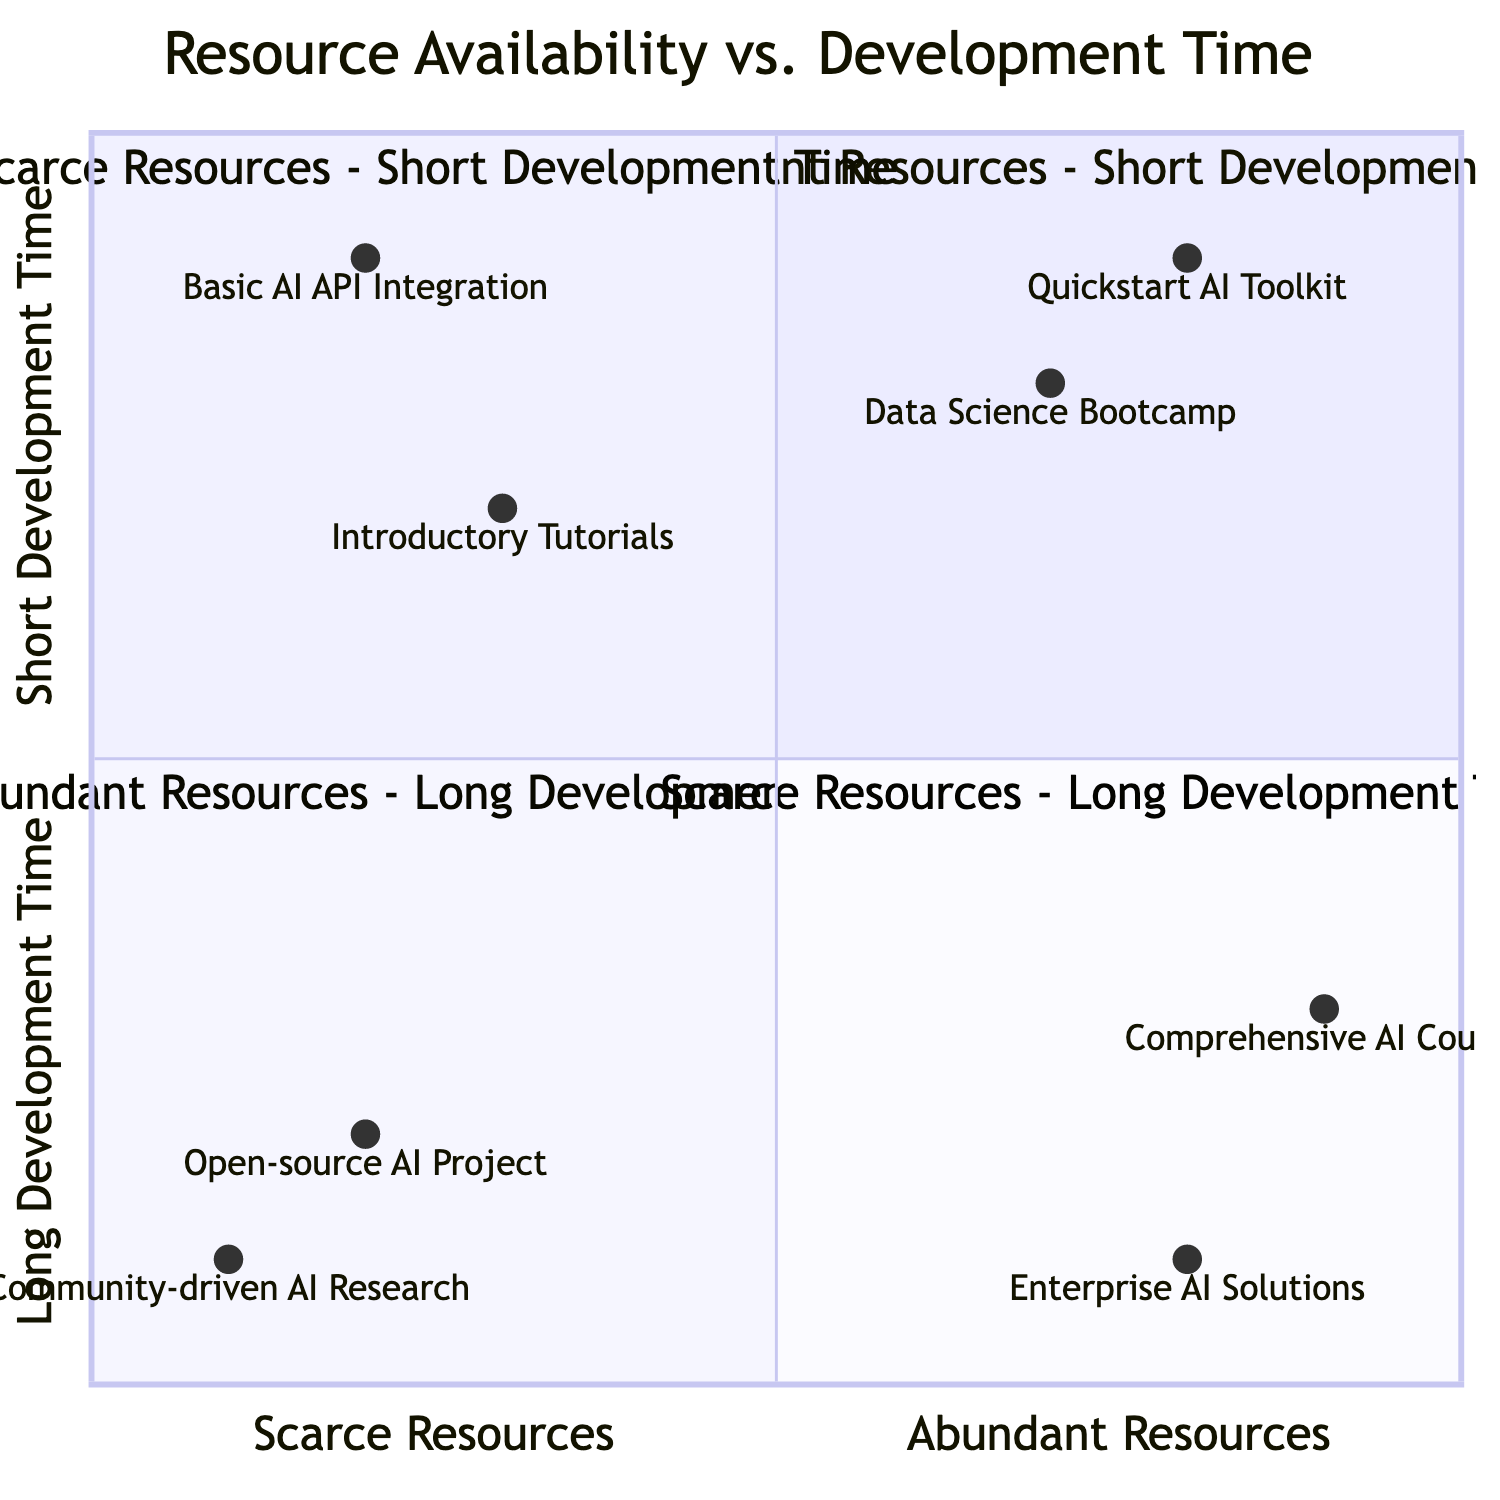What projects are located in Quadrant 1? Quadrant 1 is labeled as "Abundant Resources - Short Development Time" and includes the projects "Quickstart AI Toolkit" and "Data Science Bootcamp."
Answer: Quickstart AI Toolkit, Data Science Bootcamp How many projects are in Quadrant 4? Quadrant 4 contains two projects: "Open-source AI Project" and "Community-driven AI Research."
Answer: 2 What is the expected development time for the "Comprehensive AI Course"? The project "Comprehensive AI Course" is located in Quadrant 3, which indicates a longer development time, specifically 3-6 months.
Answer: 3-6 months Which project has the longest expected development time? In the diagram, "Community-driven AI Research" has the longest expected development time of 12-18 months, which is indicated in Quadrant 4.
Answer: 12-18 months What resources are associated with the "Data Science Bootcamp"? The "Data Science Bootcamp" in Quadrant 1 has resources such as "Online Courses" and "Interactive Jupyter Notebooks."
Answer: Online Courses, Interactive Jupyter Notebooks Which quadrant contains projects that develop quickly but have scarce resources? Quadrant 2 is defined as "Scarce Resources - Short Development Time," which includes projects that can be developed quickly but have limited resources.
Answer: Quadrant 2 What are the resources for the "Basic AI API Integration"? The project "Basic AI API Integration," which falls into Quadrant 2, has resources including "Minimal Documentation" and "Limited Data Samples."
Answer: Minimal Documentation, Limited Data Samples How many total quadrants are represented in the chart? The chart consists of four quadrants: Quadrant 1, Quadrant 2, Quadrant 3, and Quadrant 4.
Answer: 4 Which project has the most abundant resources and shortest development time? The project "Quickstart AI Toolkit," located in Quadrant 1, is characterized by abundant resources and a short development time of 1-2 weeks.
Answer: Quickstart AI Toolkit 